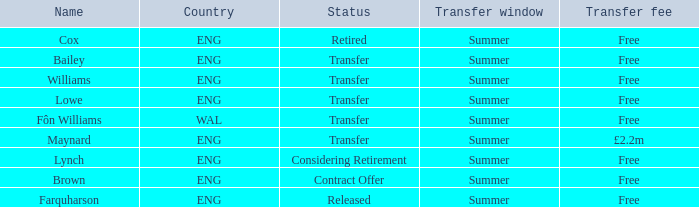What is the status of the ENG Country with the name of Farquharson? Released. 